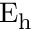<formula> <loc_0><loc_0><loc_500><loc_500>E _ { h }</formula> 